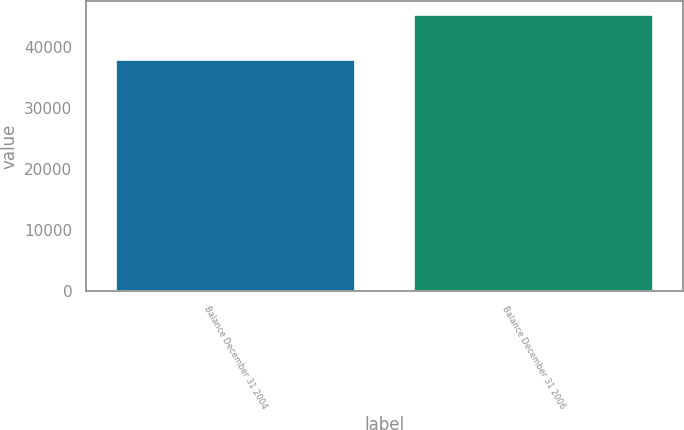Convert chart. <chart><loc_0><loc_0><loc_500><loc_500><bar_chart><fcel>Balance December 31 2004<fcel>Balance December 31 2006<nl><fcel>37781<fcel>45225<nl></chart> 